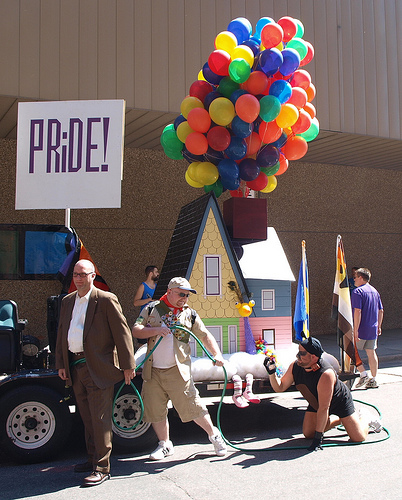<image>
Is the man on the float? No. The man is not positioned on the float. They may be near each other, but the man is not supported by or resting on top of the float. Is the sign on the man? No. The sign is not positioned on the man. They may be near each other, but the sign is not supported by or resting on top of the man. Is there a man behind the house? Yes. From this viewpoint, the man is positioned behind the house, with the house partially or fully occluding the man. Where is the sign in relation to the bald guy? Is it behind the bald guy? Yes. From this viewpoint, the sign is positioned behind the bald guy, with the bald guy partially or fully occluding the sign. 